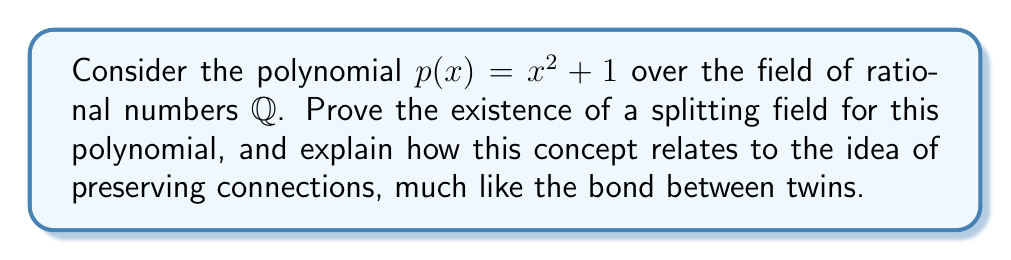What is the answer to this math problem? Let's approach this step-by-step:

1) First, recall that a splitting field for a polynomial $p(x)$ over a field $F$ is the smallest field extension of $F$ that contains all the roots of $p(x)$.

2) For $p(x) = x^2 + 1$ over $\mathbb{Q}$, we need to find its roots:
   $$x^2 + 1 = 0$$
   $$x = \pm i$$

3) The roots $i$ and $-i$ are not in $\mathbb{Q}$, so we need to extend $\mathbb{Q}$.

4) Let's construct the field extension $\mathbb{Q}(i) = \{a + bi : a, b \in \mathbb{Q}\}$.

5) To prove that $\mathbb{Q}(i)$ is indeed a field:
   a) It's closed under addition and multiplication.
   b) It has additive and multiplicative inverses for all non-zero elements.
   c) It contains $\mathbb{Q}$ as a subfield.

6) $\mathbb{Q}(i)$ contains both roots of $p(x)$, so it's a splitting field.

7) To prove it's the smallest such field:
   Any field containing $\mathbb{Q}$ and $i$ must contain all rational linear combinations of 1 and $i$, which is exactly $\mathbb{Q}(i)$.

8) Relating to the twin analogy: Just as twins share a deep connection, the original field $\mathbb{Q}$ and its extension $\mathbb{Q}(i)$ are intimately linked. The extension preserves all the properties of $\mathbb{Q}$ while adding just enough new elements to accommodate the roots of $p(x)$, much like how twins maintain their individual identities while sharing a unique bond.
Answer: $\mathbb{Q}(i)$ is the splitting field for $x^2 + 1$ over $\mathbb{Q}$. 